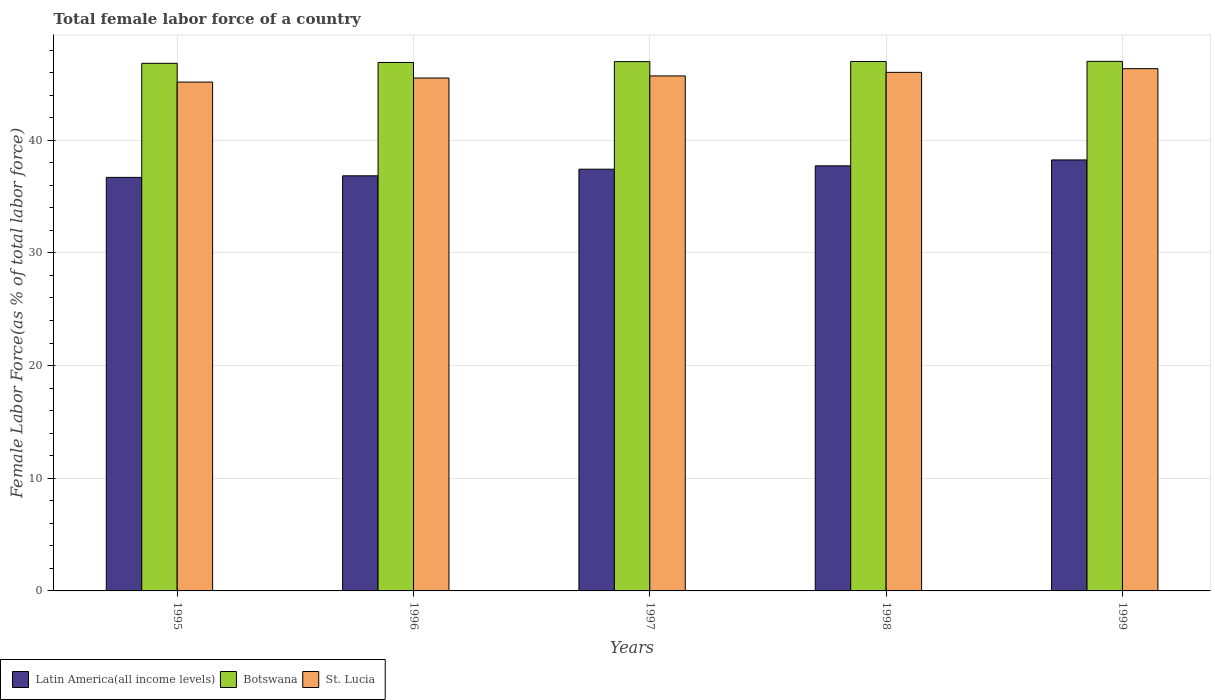How many different coloured bars are there?
Your response must be concise. 3. Are the number of bars on each tick of the X-axis equal?
Make the answer very short. Yes. How many bars are there on the 1st tick from the left?
Offer a terse response. 3. In how many cases, is the number of bars for a given year not equal to the number of legend labels?
Your answer should be compact. 0. What is the percentage of female labor force in Latin America(all income levels) in 1995?
Your response must be concise. 36.7. Across all years, what is the maximum percentage of female labor force in Latin America(all income levels)?
Give a very brief answer. 38.25. Across all years, what is the minimum percentage of female labor force in Botswana?
Ensure brevity in your answer.  46.83. In which year was the percentage of female labor force in St. Lucia minimum?
Offer a very short reply. 1995. What is the total percentage of female labor force in St. Lucia in the graph?
Provide a short and direct response. 228.79. What is the difference between the percentage of female labor force in Latin America(all income levels) in 1995 and that in 1999?
Offer a terse response. -1.55. What is the difference between the percentage of female labor force in Latin America(all income levels) in 1997 and the percentage of female labor force in Botswana in 1998?
Give a very brief answer. -9.56. What is the average percentage of female labor force in Latin America(all income levels) per year?
Offer a very short reply. 37.39. In the year 1999, what is the difference between the percentage of female labor force in Latin America(all income levels) and percentage of female labor force in Botswana?
Give a very brief answer. -8.75. In how many years, is the percentage of female labor force in St. Lucia greater than 32 %?
Keep it short and to the point. 5. What is the ratio of the percentage of female labor force in Botswana in 1996 to that in 1998?
Your answer should be very brief. 1. Is the percentage of female labor force in Latin America(all income levels) in 1996 less than that in 1999?
Provide a succinct answer. Yes. Is the difference between the percentage of female labor force in Latin America(all income levels) in 1996 and 1999 greater than the difference between the percentage of female labor force in Botswana in 1996 and 1999?
Your answer should be compact. No. What is the difference between the highest and the second highest percentage of female labor force in St. Lucia?
Offer a terse response. 0.33. What is the difference between the highest and the lowest percentage of female labor force in St. Lucia?
Keep it short and to the point. 1.19. What does the 3rd bar from the left in 1995 represents?
Your answer should be very brief. St. Lucia. What does the 3rd bar from the right in 1998 represents?
Keep it short and to the point. Latin America(all income levels). Is it the case that in every year, the sum of the percentage of female labor force in St. Lucia and percentage of female labor force in Botswana is greater than the percentage of female labor force in Latin America(all income levels)?
Your response must be concise. Yes. How many bars are there?
Offer a terse response. 15. How many years are there in the graph?
Provide a short and direct response. 5. What is the difference between two consecutive major ticks on the Y-axis?
Give a very brief answer. 10. Does the graph contain any zero values?
Your answer should be compact. No. Does the graph contain grids?
Offer a very short reply. Yes. Where does the legend appear in the graph?
Offer a very short reply. Bottom left. How many legend labels are there?
Keep it short and to the point. 3. What is the title of the graph?
Offer a very short reply. Total female labor force of a country. What is the label or title of the Y-axis?
Your response must be concise. Female Labor Force(as % of total labor force). What is the Female Labor Force(as % of total labor force) of Latin America(all income levels) in 1995?
Make the answer very short. 36.7. What is the Female Labor Force(as % of total labor force) in Botswana in 1995?
Ensure brevity in your answer.  46.83. What is the Female Labor Force(as % of total labor force) in St. Lucia in 1995?
Provide a succinct answer. 45.17. What is the Female Labor Force(as % of total labor force) in Latin America(all income levels) in 1996?
Ensure brevity in your answer.  36.85. What is the Female Labor Force(as % of total labor force) of Botswana in 1996?
Offer a very short reply. 46.91. What is the Female Labor Force(as % of total labor force) of St. Lucia in 1996?
Make the answer very short. 45.53. What is the Female Labor Force(as % of total labor force) of Latin America(all income levels) in 1997?
Keep it short and to the point. 37.43. What is the Female Labor Force(as % of total labor force) in Botswana in 1997?
Your answer should be very brief. 46.98. What is the Female Labor Force(as % of total labor force) in St. Lucia in 1997?
Keep it short and to the point. 45.71. What is the Female Labor Force(as % of total labor force) of Latin America(all income levels) in 1998?
Your answer should be compact. 37.73. What is the Female Labor Force(as % of total labor force) in Botswana in 1998?
Offer a terse response. 46.99. What is the Female Labor Force(as % of total labor force) of St. Lucia in 1998?
Your answer should be compact. 46.03. What is the Female Labor Force(as % of total labor force) in Latin America(all income levels) in 1999?
Provide a succinct answer. 38.25. What is the Female Labor Force(as % of total labor force) in Botswana in 1999?
Ensure brevity in your answer.  47. What is the Female Labor Force(as % of total labor force) of St. Lucia in 1999?
Provide a short and direct response. 46.36. Across all years, what is the maximum Female Labor Force(as % of total labor force) of Latin America(all income levels)?
Offer a terse response. 38.25. Across all years, what is the maximum Female Labor Force(as % of total labor force) in Botswana?
Your response must be concise. 47. Across all years, what is the maximum Female Labor Force(as % of total labor force) in St. Lucia?
Give a very brief answer. 46.36. Across all years, what is the minimum Female Labor Force(as % of total labor force) in Latin America(all income levels)?
Your answer should be compact. 36.7. Across all years, what is the minimum Female Labor Force(as % of total labor force) in Botswana?
Offer a very short reply. 46.83. Across all years, what is the minimum Female Labor Force(as % of total labor force) of St. Lucia?
Your answer should be very brief. 45.17. What is the total Female Labor Force(as % of total labor force) in Latin America(all income levels) in the graph?
Offer a terse response. 186.97. What is the total Female Labor Force(as % of total labor force) in Botswana in the graph?
Offer a very short reply. 234.71. What is the total Female Labor Force(as % of total labor force) in St. Lucia in the graph?
Provide a short and direct response. 228.79. What is the difference between the Female Labor Force(as % of total labor force) of Latin America(all income levels) in 1995 and that in 1996?
Offer a terse response. -0.14. What is the difference between the Female Labor Force(as % of total labor force) in Botswana in 1995 and that in 1996?
Make the answer very short. -0.08. What is the difference between the Female Labor Force(as % of total labor force) of St. Lucia in 1995 and that in 1996?
Your answer should be very brief. -0.36. What is the difference between the Female Labor Force(as % of total labor force) of Latin America(all income levels) in 1995 and that in 1997?
Your answer should be very brief. -0.73. What is the difference between the Female Labor Force(as % of total labor force) of Botswana in 1995 and that in 1997?
Offer a terse response. -0.15. What is the difference between the Female Labor Force(as % of total labor force) of St. Lucia in 1995 and that in 1997?
Ensure brevity in your answer.  -0.55. What is the difference between the Female Labor Force(as % of total labor force) of Latin America(all income levels) in 1995 and that in 1998?
Provide a short and direct response. -1.02. What is the difference between the Female Labor Force(as % of total labor force) in Botswana in 1995 and that in 1998?
Make the answer very short. -0.16. What is the difference between the Female Labor Force(as % of total labor force) of St. Lucia in 1995 and that in 1998?
Give a very brief answer. -0.86. What is the difference between the Female Labor Force(as % of total labor force) in Latin America(all income levels) in 1995 and that in 1999?
Provide a succinct answer. -1.55. What is the difference between the Female Labor Force(as % of total labor force) in Botswana in 1995 and that in 1999?
Ensure brevity in your answer.  -0.17. What is the difference between the Female Labor Force(as % of total labor force) in St. Lucia in 1995 and that in 1999?
Offer a terse response. -1.19. What is the difference between the Female Labor Force(as % of total labor force) in Latin America(all income levels) in 1996 and that in 1997?
Offer a very short reply. -0.59. What is the difference between the Female Labor Force(as % of total labor force) in Botswana in 1996 and that in 1997?
Give a very brief answer. -0.08. What is the difference between the Female Labor Force(as % of total labor force) in St. Lucia in 1996 and that in 1997?
Ensure brevity in your answer.  -0.19. What is the difference between the Female Labor Force(as % of total labor force) in Latin America(all income levels) in 1996 and that in 1998?
Provide a short and direct response. -0.88. What is the difference between the Female Labor Force(as % of total labor force) in Botswana in 1996 and that in 1998?
Ensure brevity in your answer.  -0.09. What is the difference between the Female Labor Force(as % of total labor force) of St. Lucia in 1996 and that in 1998?
Make the answer very short. -0.5. What is the difference between the Female Labor Force(as % of total labor force) of Latin America(all income levels) in 1996 and that in 1999?
Offer a terse response. -1.41. What is the difference between the Female Labor Force(as % of total labor force) in Botswana in 1996 and that in 1999?
Offer a very short reply. -0.1. What is the difference between the Female Labor Force(as % of total labor force) of St. Lucia in 1996 and that in 1999?
Offer a very short reply. -0.83. What is the difference between the Female Labor Force(as % of total labor force) in Latin America(all income levels) in 1997 and that in 1998?
Give a very brief answer. -0.3. What is the difference between the Female Labor Force(as % of total labor force) of Botswana in 1997 and that in 1998?
Your answer should be very brief. -0.01. What is the difference between the Female Labor Force(as % of total labor force) of St. Lucia in 1997 and that in 1998?
Your answer should be very brief. -0.32. What is the difference between the Female Labor Force(as % of total labor force) of Latin America(all income levels) in 1997 and that in 1999?
Make the answer very short. -0.82. What is the difference between the Female Labor Force(as % of total labor force) in Botswana in 1997 and that in 1999?
Your response must be concise. -0.02. What is the difference between the Female Labor Force(as % of total labor force) of St. Lucia in 1997 and that in 1999?
Your response must be concise. -0.64. What is the difference between the Female Labor Force(as % of total labor force) in Latin America(all income levels) in 1998 and that in 1999?
Keep it short and to the point. -0.53. What is the difference between the Female Labor Force(as % of total labor force) of Botswana in 1998 and that in 1999?
Offer a very short reply. -0.01. What is the difference between the Female Labor Force(as % of total labor force) of St. Lucia in 1998 and that in 1999?
Your answer should be compact. -0.33. What is the difference between the Female Labor Force(as % of total labor force) in Latin America(all income levels) in 1995 and the Female Labor Force(as % of total labor force) in Botswana in 1996?
Your answer should be compact. -10.2. What is the difference between the Female Labor Force(as % of total labor force) of Latin America(all income levels) in 1995 and the Female Labor Force(as % of total labor force) of St. Lucia in 1996?
Offer a very short reply. -8.82. What is the difference between the Female Labor Force(as % of total labor force) of Botswana in 1995 and the Female Labor Force(as % of total labor force) of St. Lucia in 1996?
Offer a very short reply. 1.3. What is the difference between the Female Labor Force(as % of total labor force) in Latin America(all income levels) in 1995 and the Female Labor Force(as % of total labor force) in Botswana in 1997?
Offer a terse response. -10.28. What is the difference between the Female Labor Force(as % of total labor force) in Latin America(all income levels) in 1995 and the Female Labor Force(as % of total labor force) in St. Lucia in 1997?
Provide a succinct answer. -9.01. What is the difference between the Female Labor Force(as % of total labor force) of Botswana in 1995 and the Female Labor Force(as % of total labor force) of St. Lucia in 1997?
Ensure brevity in your answer.  1.12. What is the difference between the Female Labor Force(as % of total labor force) in Latin America(all income levels) in 1995 and the Female Labor Force(as % of total labor force) in Botswana in 1998?
Offer a terse response. -10.29. What is the difference between the Female Labor Force(as % of total labor force) in Latin America(all income levels) in 1995 and the Female Labor Force(as % of total labor force) in St. Lucia in 1998?
Provide a short and direct response. -9.32. What is the difference between the Female Labor Force(as % of total labor force) of Botswana in 1995 and the Female Labor Force(as % of total labor force) of St. Lucia in 1998?
Your answer should be very brief. 0.8. What is the difference between the Female Labor Force(as % of total labor force) in Latin America(all income levels) in 1995 and the Female Labor Force(as % of total labor force) in Botswana in 1999?
Give a very brief answer. -10.3. What is the difference between the Female Labor Force(as % of total labor force) in Latin America(all income levels) in 1995 and the Female Labor Force(as % of total labor force) in St. Lucia in 1999?
Give a very brief answer. -9.65. What is the difference between the Female Labor Force(as % of total labor force) of Botswana in 1995 and the Female Labor Force(as % of total labor force) of St. Lucia in 1999?
Provide a short and direct response. 0.47. What is the difference between the Female Labor Force(as % of total labor force) of Latin America(all income levels) in 1996 and the Female Labor Force(as % of total labor force) of Botswana in 1997?
Make the answer very short. -10.14. What is the difference between the Female Labor Force(as % of total labor force) of Latin America(all income levels) in 1996 and the Female Labor Force(as % of total labor force) of St. Lucia in 1997?
Make the answer very short. -8.87. What is the difference between the Female Labor Force(as % of total labor force) in Botswana in 1996 and the Female Labor Force(as % of total labor force) in St. Lucia in 1997?
Your answer should be very brief. 1.19. What is the difference between the Female Labor Force(as % of total labor force) in Latin America(all income levels) in 1996 and the Female Labor Force(as % of total labor force) in Botswana in 1998?
Your answer should be very brief. -10.15. What is the difference between the Female Labor Force(as % of total labor force) in Latin America(all income levels) in 1996 and the Female Labor Force(as % of total labor force) in St. Lucia in 1998?
Keep it short and to the point. -9.18. What is the difference between the Female Labor Force(as % of total labor force) of Botswana in 1996 and the Female Labor Force(as % of total labor force) of St. Lucia in 1998?
Ensure brevity in your answer.  0.88. What is the difference between the Female Labor Force(as % of total labor force) in Latin America(all income levels) in 1996 and the Female Labor Force(as % of total labor force) in Botswana in 1999?
Offer a terse response. -10.16. What is the difference between the Female Labor Force(as % of total labor force) of Latin America(all income levels) in 1996 and the Female Labor Force(as % of total labor force) of St. Lucia in 1999?
Give a very brief answer. -9.51. What is the difference between the Female Labor Force(as % of total labor force) in Botswana in 1996 and the Female Labor Force(as % of total labor force) in St. Lucia in 1999?
Your response must be concise. 0.55. What is the difference between the Female Labor Force(as % of total labor force) in Latin America(all income levels) in 1997 and the Female Labor Force(as % of total labor force) in Botswana in 1998?
Provide a succinct answer. -9.56. What is the difference between the Female Labor Force(as % of total labor force) of Latin America(all income levels) in 1997 and the Female Labor Force(as % of total labor force) of St. Lucia in 1998?
Offer a very short reply. -8.6. What is the difference between the Female Labor Force(as % of total labor force) in Botswana in 1997 and the Female Labor Force(as % of total labor force) in St. Lucia in 1998?
Your response must be concise. 0.95. What is the difference between the Female Labor Force(as % of total labor force) of Latin America(all income levels) in 1997 and the Female Labor Force(as % of total labor force) of Botswana in 1999?
Ensure brevity in your answer.  -9.57. What is the difference between the Female Labor Force(as % of total labor force) in Latin America(all income levels) in 1997 and the Female Labor Force(as % of total labor force) in St. Lucia in 1999?
Provide a succinct answer. -8.92. What is the difference between the Female Labor Force(as % of total labor force) in Botswana in 1997 and the Female Labor Force(as % of total labor force) in St. Lucia in 1999?
Your response must be concise. 0.63. What is the difference between the Female Labor Force(as % of total labor force) of Latin America(all income levels) in 1998 and the Female Labor Force(as % of total labor force) of Botswana in 1999?
Keep it short and to the point. -9.28. What is the difference between the Female Labor Force(as % of total labor force) of Latin America(all income levels) in 1998 and the Female Labor Force(as % of total labor force) of St. Lucia in 1999?
Provide a succinct answer. -8.63. What is the difference between the Female Labor Force(as % of total labor force) in Botswana in 1998 and the Female Labor Force(as % of total labor force) in St. Lucia in 1999?
Keep it short and to the point. 0.64. What is the average Female Labor Force(as % of total labor force) in Latin America(all income levels) per year?
Your answer should be compact. 37.39. What is the average Female Labor Force(as % of total labor force) of Botswana per year?
Provide a succinct answer. 46.94. What is the average Female Labor Force(as % of total labor force) in St. Lucia per year?
Keep it short and to the point. 45.76. In the year 1995, what is the difference between the Female Labor Force(as % of total labor force) in Latin America(all income levels) and Female Labor Force(as % of total labor force) in Botswana?
Your response must be concise. -10.12. In the year 1995, what is the difference between the Female Labor Force(as % of total labor force) of Latin America(all income levels) and Female Labor Force(as % of total labor force) of St. Lucia?
Give a very brief answer. -8.46. In the year 1995, what is the difference between the Female Labor Force(as % of total labor force) in Botswana and Female Labor Force(as % of total labor force) in St. Lucia?
Offer a very short reply. 1.66. In the year 1996, what is the difference between the Female Labor Force(as % of total labor force) of Latin America(all income levels) and Female Labor Force(as % of total labor force) of Botswana?
Make the answer very short. -10.06. In the year 1996, what is the difference between the Female Labor Force(as % of total labor force) in Latin America(all income levels) and Female Labor Force(as % of total labor force) in St. Lucia?
Give a very brief answer. -8.68. In the year 1996, what is the difference between the Female Labor Force(as % of total labor force) in Botswana and Female Labor Force(as % of total labor force) in St. Lucia?
Your answer should be very brief. 1.38. In the year 1997, what is the difference between the Female Labor Force(as % of total labor force) in Latin America(all income levels) and Female Labor Force(as % of total labor force) in Botswana?
Your response must be concise. -9.55. In the year 1997, what is the difference between the Female Labor Force(as % of total labor force) of Latin America(all income levels) and Female Labor Force(as % of total labor force) of St. Lucia?
Your response must be concise. -8.28. In the year 1997, what is the difference between the Female Labor Force(as % of total labor force) in Botswana and Female Labor Force(as % of total labor force) in St. Lucia?
Your response must be concise. 1.27. In the year 1998, what is the difference between the Female Labor Force(as % of total labor force) of Latin America(all income levels) and Female Labor Force(as % of total labor force) of Botswana?
Your answer should be very brief. -9.27. In the year 1998, what is the difference between the Female Labor Force(as % of total labor force) of Latin America(all income levels) and Female Labor Force(as % of total labor force) of St. Lucia?
Provide a short and direct response. -8.3. In the year 1998, what is the difference between the Female Labor Force(as % of total labor force) in Botswana and Female Labor Force(as % of total labor force) in St. Lucia?
Your answer should be compact. 0.97. In the year 1999, what is the difference between the Female Labor Force(as % of total labor force) in Latin America(all income levels) and Female Labor Force(as % of total labor force) in Botswana?
Offer a terse response. -8.75. In the year 1999, what is the difference between the Female Labor Force(as % of total labor force) of Latin America(all income levels) and Female Labor Force(as % of total labor force) of St. Lucia?
Provide a short and direct response. -8.1. In the year 1999, what is the difference between the Female Labor Force(as % of total labor force) of Botswana and Female Labor Force(as % of total labor force) of St. Lucia?
Offer a very short reply. 0.65. What is the ratio of the Female Labor Force(as % of total labor force) of Latin America(all income levels) in 1995 to that in 1997?
Offer a very short reply. 0.98. What is the ratio of the Female Labor Force(as % of total labor force) in St. Lucia in 1995 to that in 1997?
Offer a terse response. 0.99. What is the ratio of the Female Labor Force(as % of total labor force) of Latin America(all income levels) in 1995 to that in 1998?
Your answer should be compact. 0.97. What is the ratio of the Female Labor Force(as % of total labor force) in St. Lucia in 1995 to that in 1998?
Your answer should be very brief. 0.98. What is the ratio of the Female Labor Force(as % of total labor force) in Latin America(all income levels) in 1995 to that in 1999?
Your answer should be very brief. 0.96. What is the ratio of the Female Labor Force(as % of total labor force) in St. Lucia in 1995 to that in 1999?
Make the answer very short. 0.97. What is the ratio of the Female Labor Force(as % of total labor force) in Latin America(all income levels) in 1996 to that in 1997?
Ensure brevity in your answer.  0.98. What is the ratio of the Female Labor Force(as % of total labor force) of St. Lucia in 1996 to that in 1997?
Provide a short and direct response. 1. What is the ratio of the Female Labor Force(as % of total labor force) in Latin America(all income levels) in 1996 to that in 1998?
Offer a very short reply. 0.98. What is the ratio of the Female Labor Force(as % of total labor force) of Botswana in 1996 to that in 1998?
Give a very brief answer. 1. What is the ratio of the Female Labor Force(as % of total labor force) in St. Lucia in 1996 to that in 1998?
Your answer should be compact. 0.99. What is the ratio of the Female Labor Force(as % of total labor force) of Latin America(all income levels) in 1996 to that in 1999?
Your response must be concise. 0.96. What is the ratio of the Female Labor Force(as % of total labor force) of Botswana in 1996 to that in 1999?
Your response must be concise. 1. What is the ratio of the Female Labor Force(as % of total labor force) in St. Lucia in 1996 to that in 1999?
Ensure brevity in your answer.  0.98. What is the ratio of the Female Labor Force(as % of total labor force) of Latin America(all income levels) in 1997 to that in 1998?
Give a very brief answer. 0.99. What is the ratio of the Female Labor Force(as % of total labor force) in Botswana in 1997 to that in 1998?
Provide a short and direct response. 1. What is the ratio of the Female Labor Force(as % of total labor force) of Latin America(all income levels) in 1997 to that in 1999?
Provide a short and direct response. 0.98. What is the ratio of the Female Labor Force(as % of total labor force) in Botswana in 1997 to that in 1999?
Keep it short and to the point. 1. What is the ratio of the Female Labor Force(as % of total labor force) of St. Lucia in 1997 to that in 1999?
Offer a very short reply. 0.99. What is the ratio of the Female Labor Force(as % of total labor force) in Latin America(all income levels) in 1998 to that in 1999?
Your answer should be compact. 0.99. What is the ratio of the Female Labor Force(as % of total labor force) in St. Lucia in 1998 to that in 1999?
Ensure brevity in your answer.  0.99. What is the difference between the highest and the second highest Female Labor Force(as % of total labor force) in Latin America(all income levels)?
Provide a short and direct response. 0.53. What is the difference between the highest and the second highest Female Labor Force(as % of total labor force) of Botswana?
Provide a succinct answer. 0.01. What is the difference between the highest and the second highest Female Labor Force(as % of total labor force) in St. Lucia?
Your answer should be compact. 0.33. What is the difference between the highest and the lowest Female Labor Force(as % of total labor force) in Latin America(all income levels)?
Make the answer very short. 1.55. What is the difference between the highest and the lowest Female Labor Force(as % of total labor force) of Botswana?
Provide a short and direct response. 0.17. What is the difference between the highest and the lowest Female Labor Force(as % of total labor force) of St. Lucia?
Your response must be concise. 1.19. 